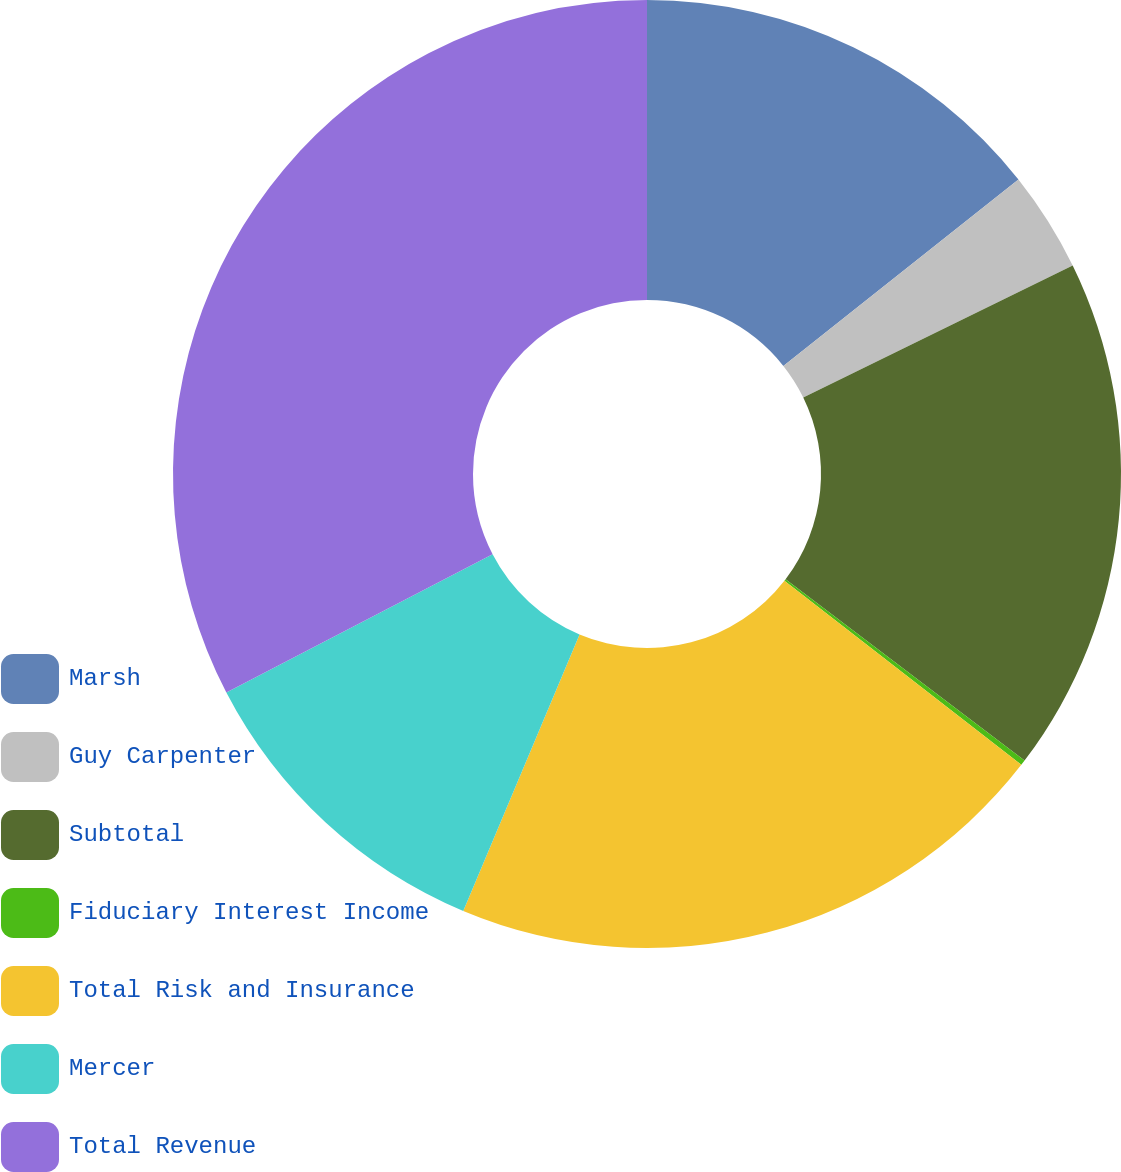Convert chart. <chart><loc_0><loc_0><loc_500><loc_500><pie_chart><fcel>Marsh<fcel>Guy Carpenter<fcel>Subtotal<fcel>Fiduciary Interest Income<fcel>Total Risk and Insurance<fcel>Mercer<fcel>Total Revenue<nl><fcel>14.33%<fcel>3.42%<fcel>17.58%<fcel>0.18%<fcel>20.82%<fcel>11.04%<fcel>32.62%<nl></chart> 